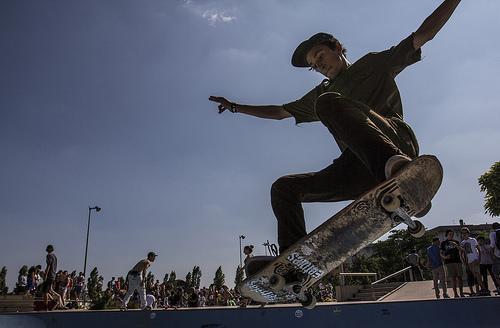How many people are actively skateboarding?
Give a very brief answer. 2. 